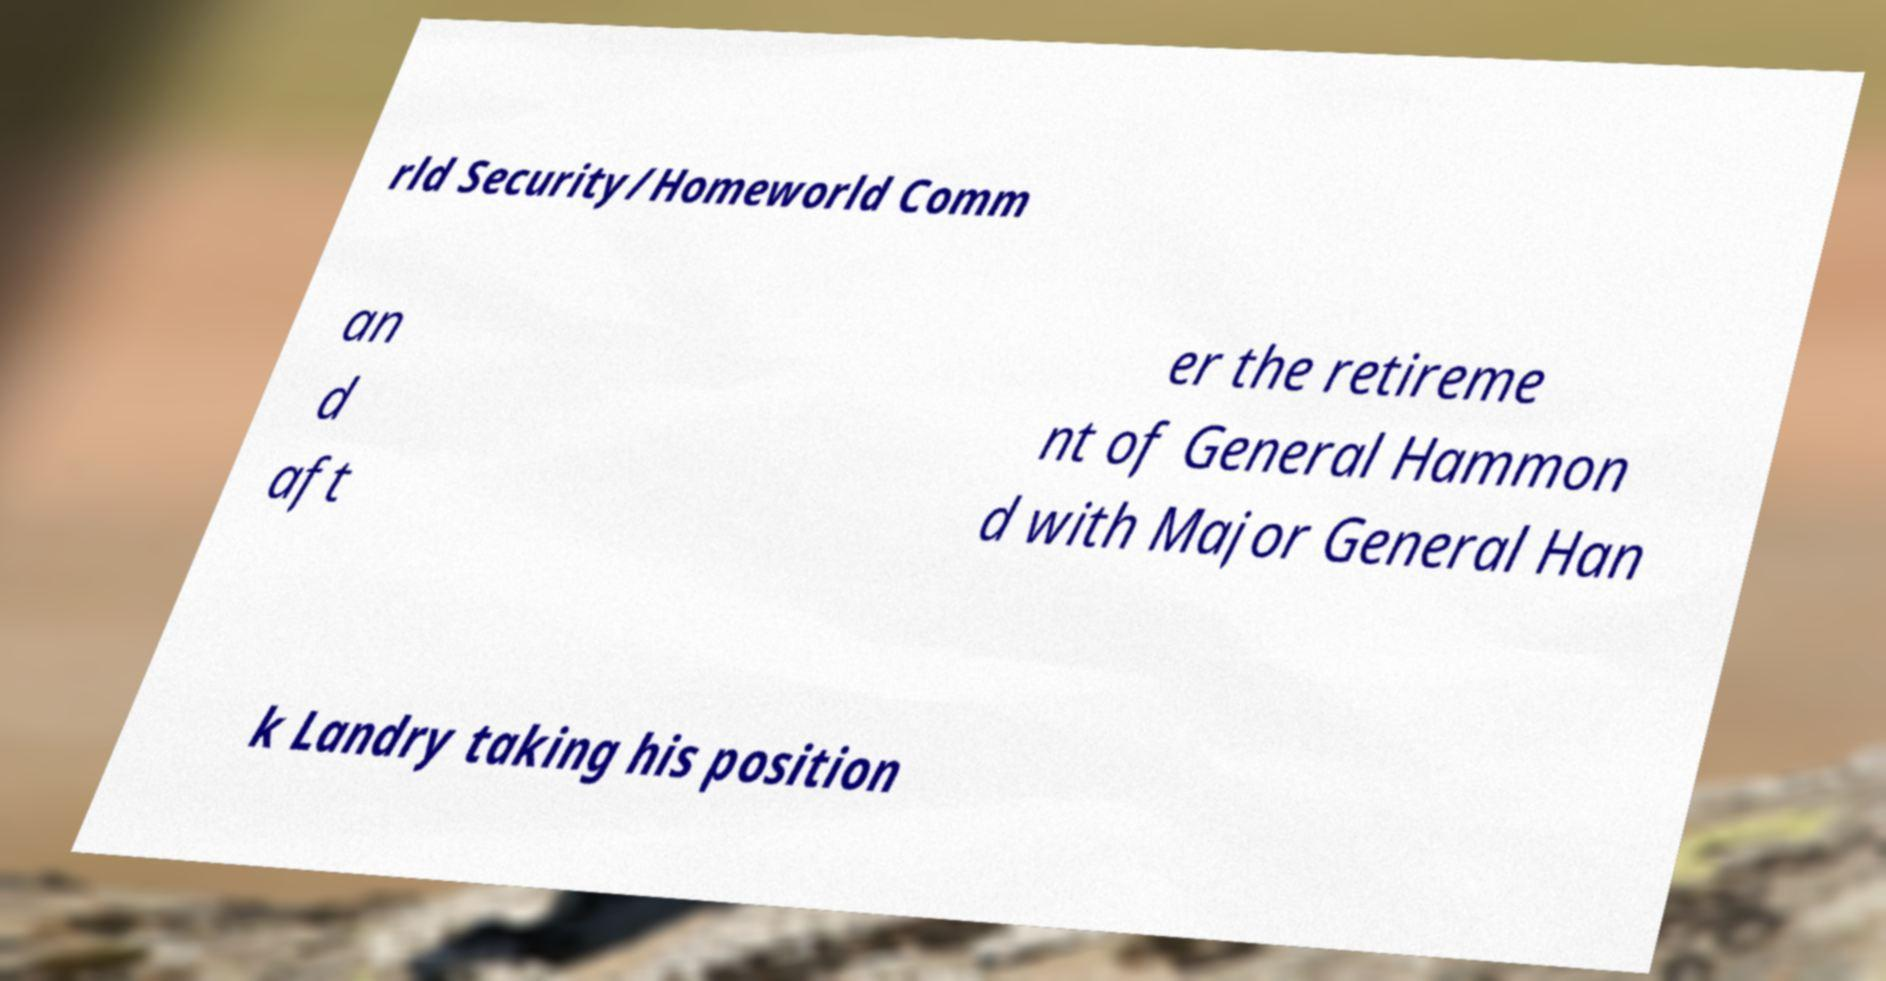Can you read and provide the text displayed in the image?This photo seems to have some interesting text. Can you extract and type it out for me? rld Security/Homeworld Comm an d aft er the retireme nt of General Hammon d with Major General Han k Landry taking his position 